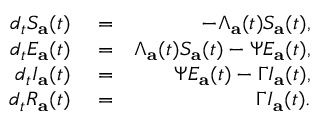<formula> <loc_0><loc_0><loc_500><loc_500>\begin{array} { r l r } { d _ { t } S _ { a } ( t ) } & = } & { - \Lambda _ { a } ( t ) S _ { a } ( t ) , } \\ { d _ { t } E _ { a } ( t ) } & = } & { \Lambda _ { a } ( t ) S _ { a } ( t ) - \Psi E _ { a } ( t ) , } \\ { d _ { t } I _ { a } ( t ) } & = } & { \Psi E _ { a } ( t ) - \Gamma I _ { a } ( t ) , } \\ { d _ { t } R _ { a } ( t ) } & = } & { \Gamma I _ { a } ( t ) . } \end{array}</formula> 